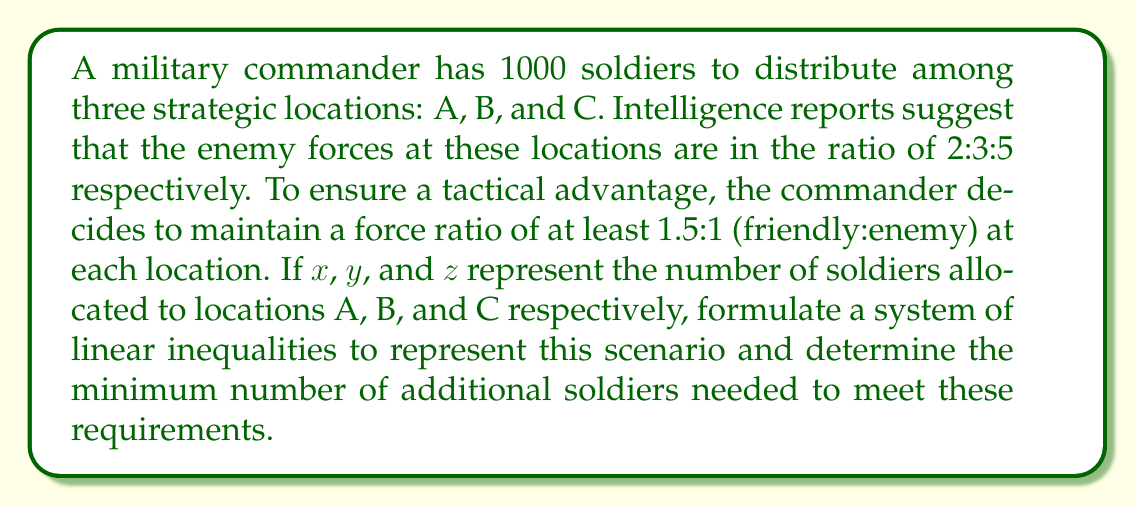Provide a solution to this math problem. 1. Let's establish the inequalities based on the force ratio requirement:

   Location A: $x \geq 1.5 \cdot 2k$
   Location B: $y \geq 1.5 \cdot 3k$
   Location C: $z \geq 1.5 \cdot 5k$

   Where $k$ is a scaling factor for enemy forces.

2. We also know that the total number of soldiers is 1000:

   $x + y + z = 1000$

3. Simplifying the inequalities:

   $x \geq 3k$
   $y \geq 4.5k$
   $z \geq 7.5k$

4. Adding these inequalities:

   $x + y + z \geq 15k$

5. Since $x + y + z = 1000$, we can write:

   $1000 \geq 15k$

6. Solving for $k$:

   $k \leq \frac{1000}{15} \approx 66.67$

7. To ensure integer values, we round down:

   $k = 66$

8. Now, we can calculate the minimum number of soldiers needed at each location:

   A: $3k = 3 \cdot 66 = 198$
   B: $4.5k = 4.5 \cdot 66 = 297$
   C: $7.5k = 7.5 \cdot 66 = 495$

9. The total number of soldiers needed is:

   $198 + 297 + 495 = 990$

10. The additional soldiers needed:

    $990 - 1000 = -10$

Since this is negative, no additional soldiers are needed.
Answer: 0 